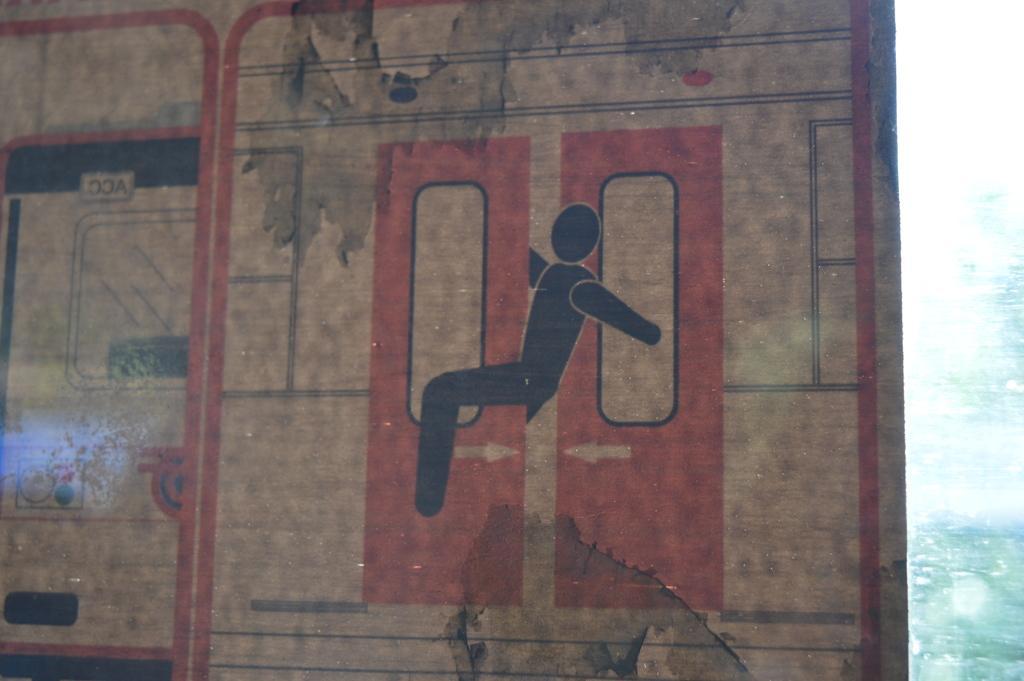Could you give a brief overview of what you see in this image? In this image I can see the sign board which is cream, red and brown in color. I can see the white and green colored background. 